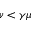<formula> <loc_0><loc_0><loc_500><loc_500>\nu < \gamma \mu</formula> 